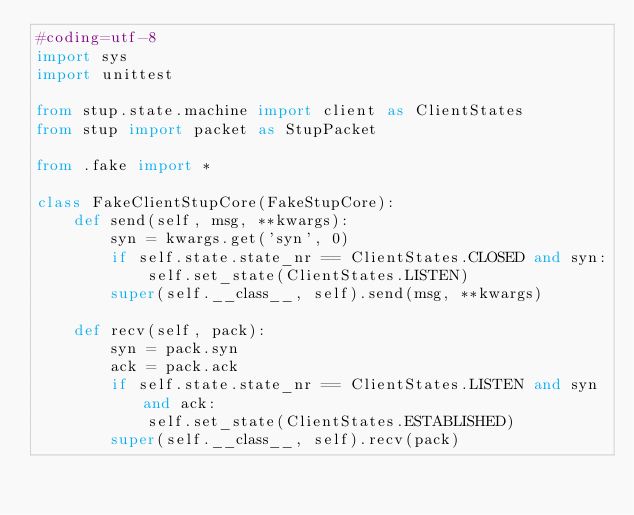<code> <loc_0><loc_0><loc_500><loc_500><_Python_>#coding=utf-8
import sys
import unittest

from stup.state.machine import client as ClientStates
from stup import packet as StupPacket

from .fake import *

class FakeClientStupCore(FakeStupCore):
    def send(self, msg, **kwargs):
        syn = kwargs.get('syn', 0)
        if self.state.state_nr == ClientStates.CLOSED and syn:
            self.set_state(ClientStates.LISTEN)
        super(self.__class__, self).send(msg, **kwargs)

    def recv(self, pack):
        syn = pack.syn
        ack = pack.ack
        if self.state.state_nr == ClientStates.LISTEN and syn and ack:
            self.set_state(ClientStates.ESTABLISHED)
        super(self.__class__, self).recv(pack)
</code> 